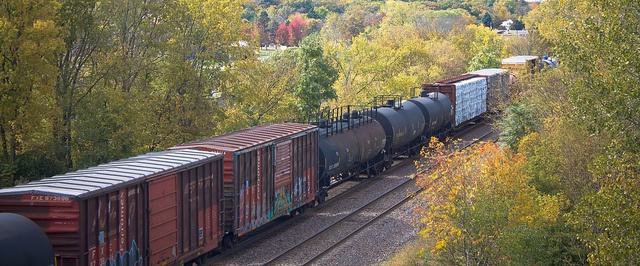Describe the objects in this image and their specific colors. I can see a train in gray, black, and maroon tones in this image. 